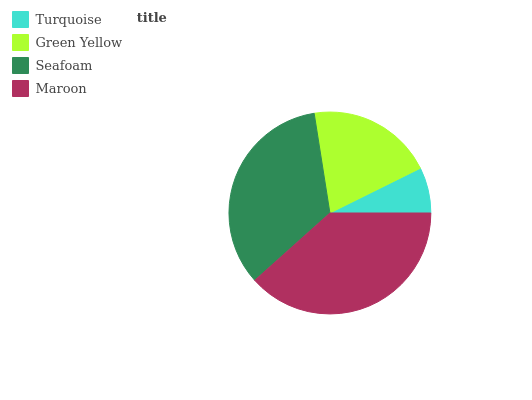Is Turquoise the minimum?
Answer yes or no. Yes. Is Maroon the maximum?
Answer yes or no. Yes. Is Green Yellow the minimum?
Answer yes or no. No. Is Green Yellow the maximum?
Answer yes or no. No. Is Green Yellow greater than Turquoise?
Answer yes or no. Yes. Is Turquoise less than Green Yellow?
Answer yes or no. Yes. Is Turquoise greater than Green Yellow?
Answer yes or no. No. Is Green Yellow less than Turquoise?
Answer yes or no. No. Is Seafoam the high median?
Answer yes or no. Yes. Is Green Yellow the low median?
Answer yes or no. Yes. Is Turquoise the high median?
Answer yes or no. No. Is Maroon the low median?
Answer yes or no. No. 